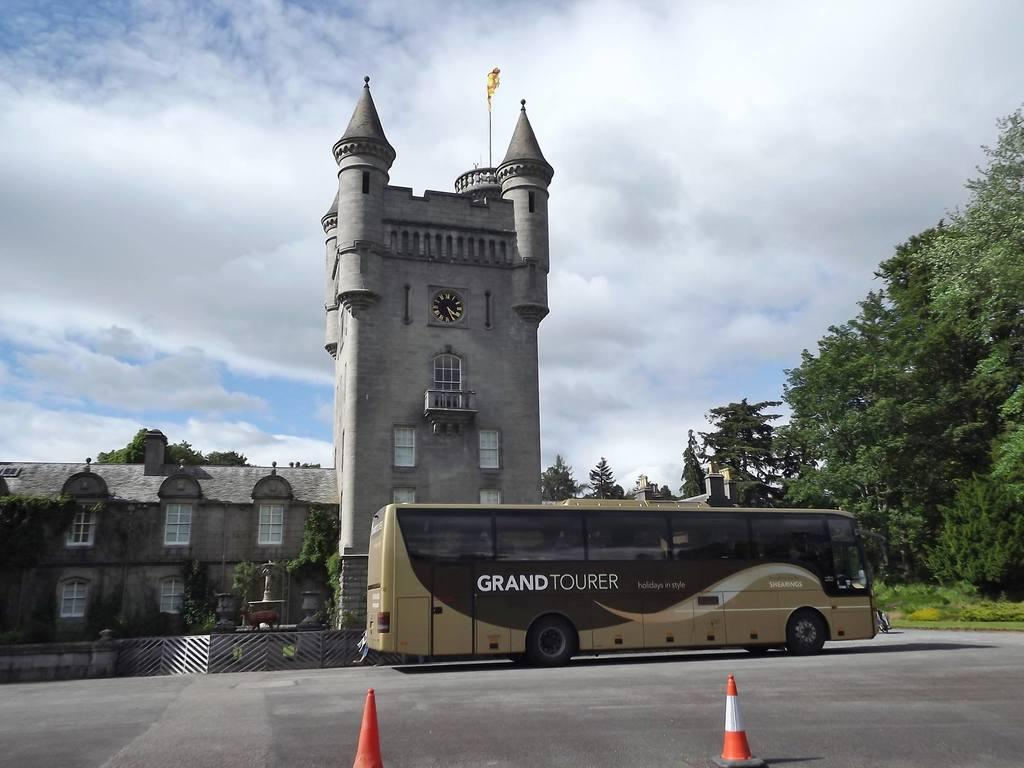What is the main subject of the image? The main subject of the image is a bus. Where is the bus located in the image? The bus is on a road in the image. What can be seen in the background of the image? There is a building, trees, and the sky visible in the background of the image. Can you tell me how many books are in the library in the image? There is no library present in the image, so it is not possible to determine how many books might be there. What type of need is being used by the bus driver in the image? There is no reference to a need in the image, as it features a bus on a road with a background of a building, trees, and the sky. 